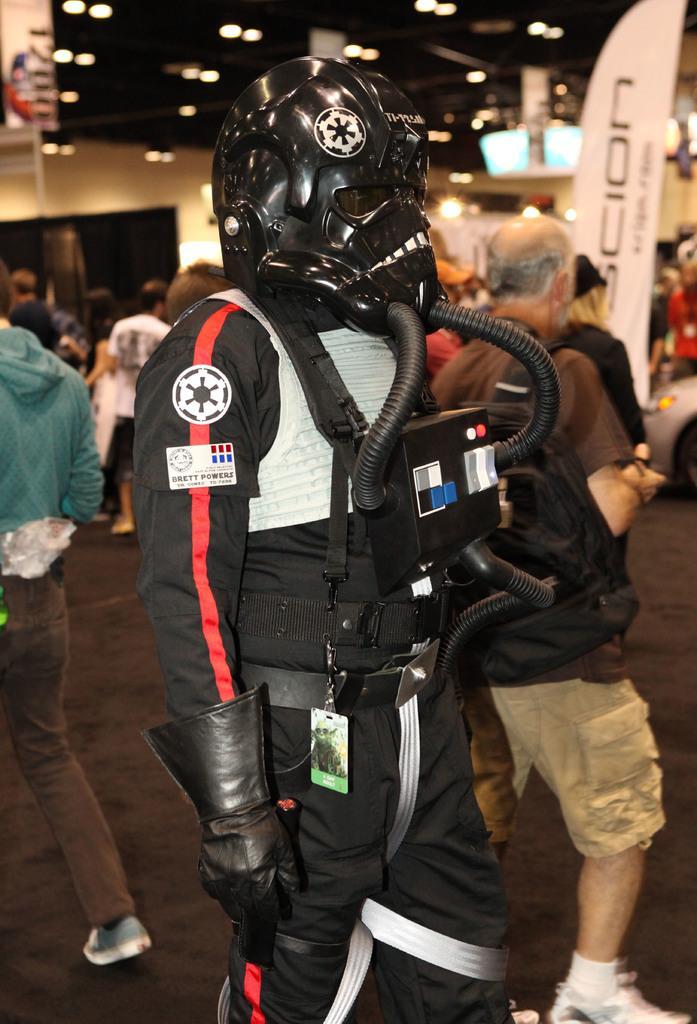Please provide a concise description of this image. In this image we can see a person wearing black color dress, helmet and gloves standing and in the background of the image there are some group of persons standing, there is wall and some lights. 